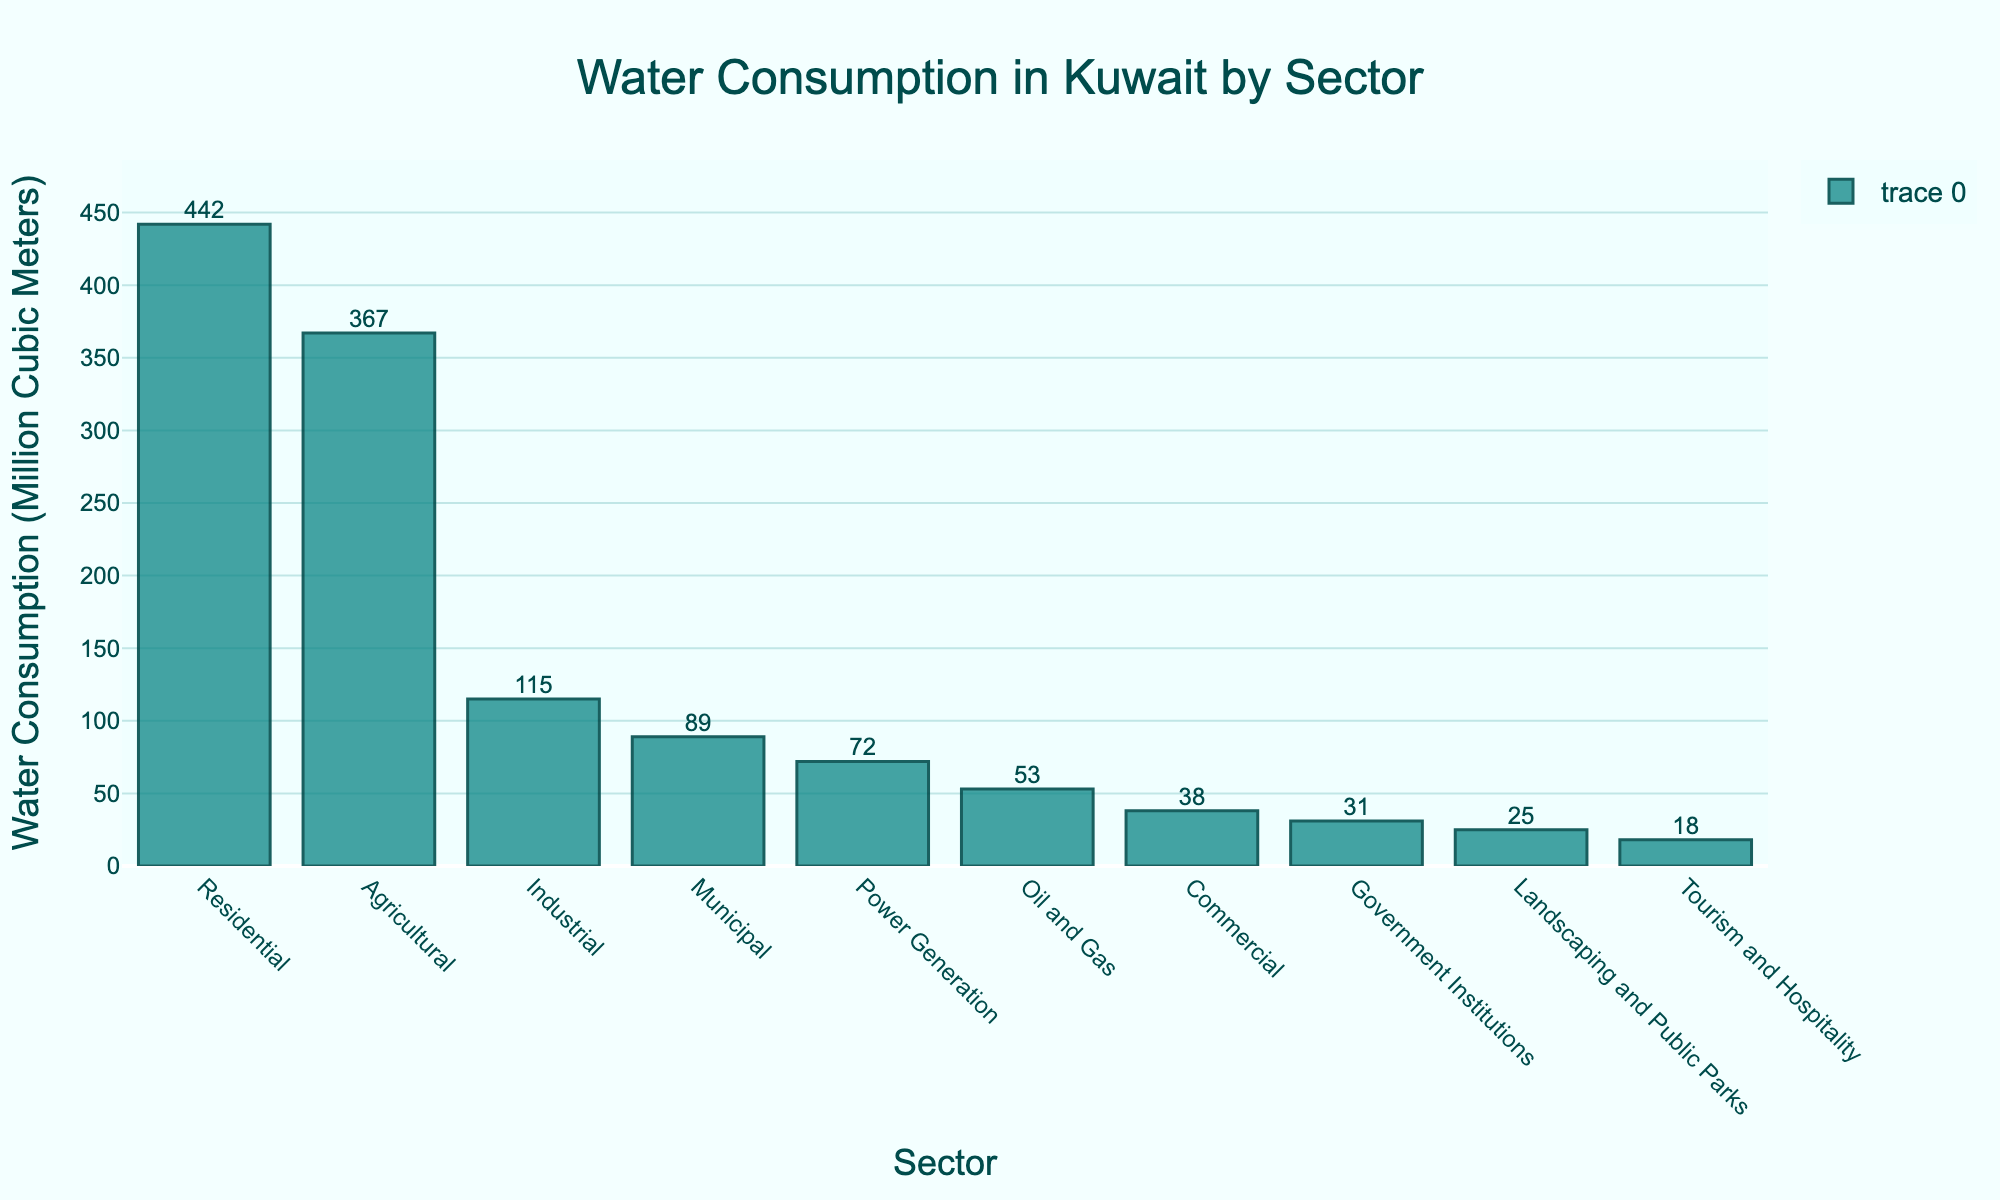What sector has the highest water consumption? The highest bar represents the sector with the highest water consumption. In the figure, the sector with the highest water consumption is Residential.
Answer: Residential Which sector has the lowest water consumption? The lowest bar represents the sector with the lowest water consumption. In the figure, the sector with the lowest water consumption is Tourism and Hospitality.
Answer: Tourism and Hospitality What is the total water consumption of the Agricultural and Industrial sectors combined? We need to add the water consumption of the Agricultural sector (367 million cubic meters) and the Industrial sector (115 million cubic meters). So, 367 + 115 = 482 million cubic meters.
Answer: 482 million cubic meters How much more water does the Residential sector consume compared to the Commercial sector? To find out how much more water the Residential sector consumes compared to the Commercial sector, we subtract the water consumption of the Commercial sector from the Residential sector. Residential (442 million cubic meters) - Commercial (38 million cubic meters) = 404 million cubic meters.
Answer: 404 million cubic meters Is water consumption in the Oil and Gas sector greater than in the Government Institutions sector? We compare the heights of the bars for the Oil and Gas sector and the Government Institutions sector. The Oil and Gas sector consumes 53 million cubic meters, while the Government Institutions sector consumes 31 million cubic meters, so yes, it is greater.
Answer: Yes What is the average water consumption of the top three sectors? We identify the top three sectors by their water consumption: Residential (442), Agricultural (367), and Industrial (115). Adding these up gives 442 + 367 + 115 = 924. Averaging these by dividing by 3, we get 924 / 3 = 308 million cubic meters.
Answer: 308 million cubic meters What is the difference in water consumption between Municipal and Landscaping and Public Parks sectors? To find the difference, subtract the water consumption of the Landscaping and Public Parks sector from the Municipal sector. Municipal (89 million cubic meters) - Landscaping and Public Parks (25 million cubic meters) = 64 million cubic meters.
Answer: 64 million cubic meters Which sectors have a water consumption greater than 100 million cubic meters? We look at the bars that exceed the 100 million cubic meters mark. The sectors are Residential (442), Agricultural (367), and Industrial (115).
Answer: Residential, Agricultural, Industrial What's the cumulative water consumption of sectors with less than or equal to 50 million cubic meters use? We find the bars with consumption <= 50 million cubic meters: Oil and Gas (53 is excluded), Commercial (38), Government Institutions (31), Landscaping and Public Parks (25), Tourism and Hospitality (18). Summing these values: 38 + 31 + 25 + 18 = 112 million cubic meters.
Answer: 112 million cubic meters 